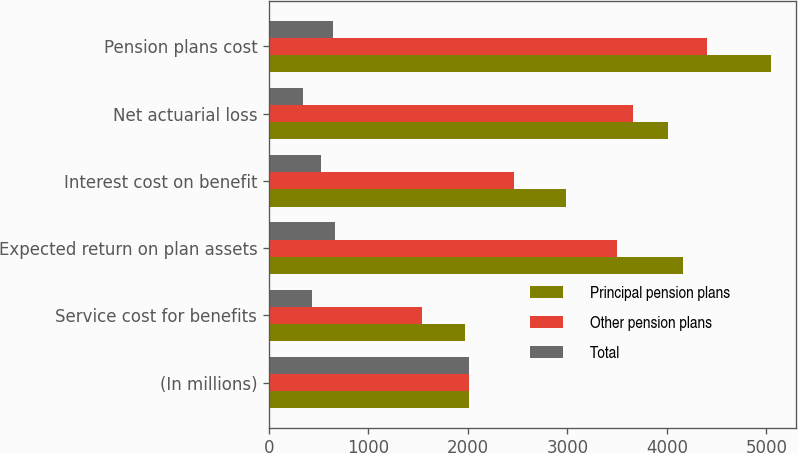Convert chart. <chart><loc_0><loc_0><loc_500><loc_500><stacked_bar_chart><ecel><fcel>(In millions)<fcel>Service cost for benefits<fcel>Expected return on plan assets<fcel>Interest cost on benefit<fcel>Net actuarial loss<fcel>Pension plans cost<nl><fcel>Principal pension plans<fcel>2013<fcel>1970<fcel>4163<fcel>2983<fcel>4007<fcel>5050<nl><fcel>Other pension plans<fcel>2013<fcel>1535<fcel>3500<fcel>2460<fcel>3664<fcel>4405<nl><fcel>Total<fcel>2013<fcel>435<fcel>663<fcel>523<fcel>343<fcel>645<nl></chart> 